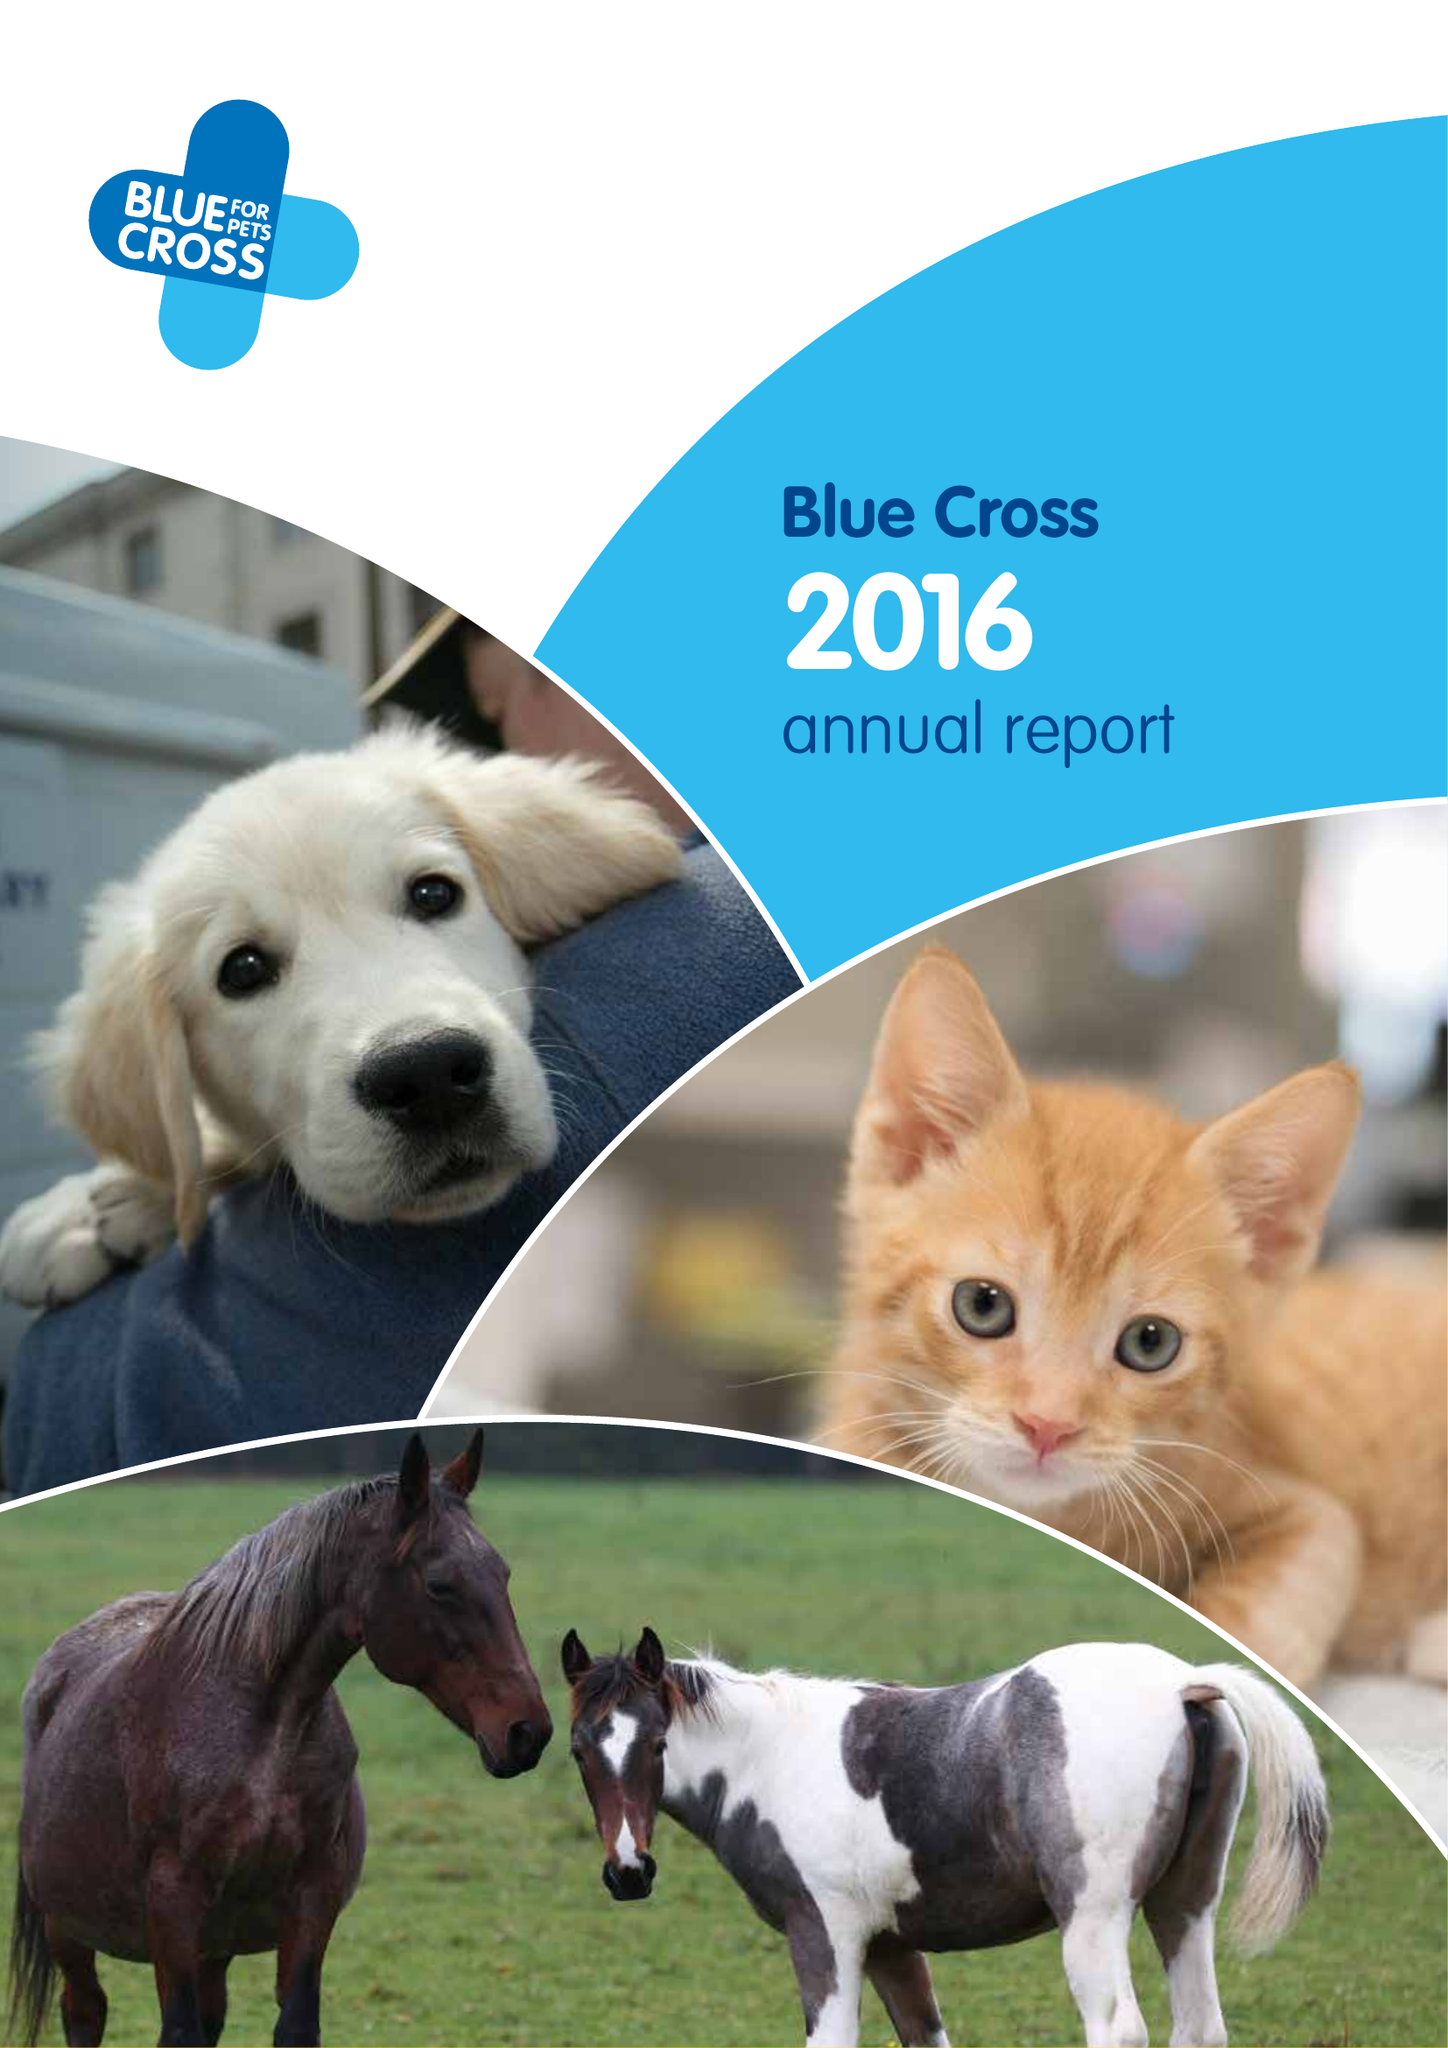What is the value for the address__street_line?
Answer the question using a single word or phrase. SHILTON ROAD 